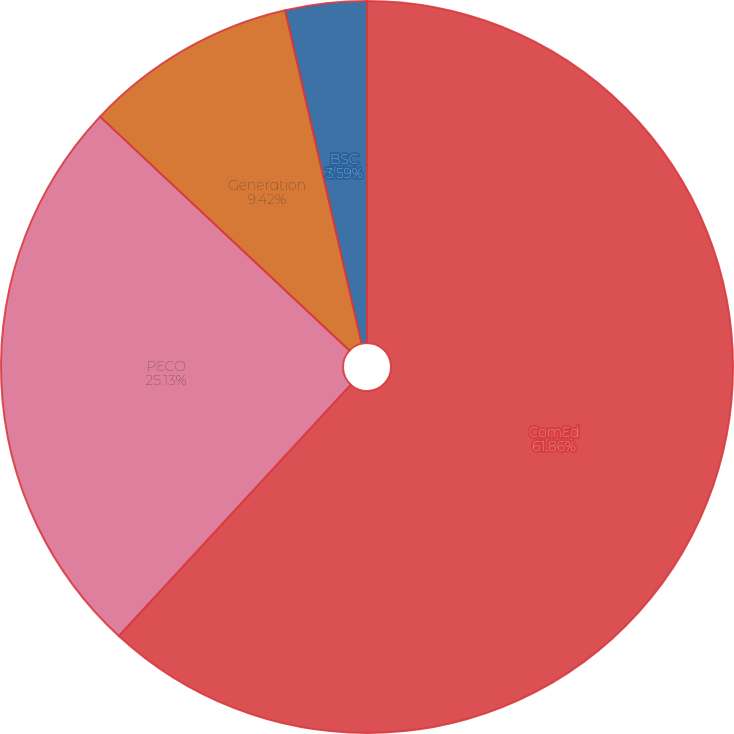Convert chart to OTSL. <chart><loc_0><loc_0><loc_500><loc_500><pie_chart><fcel>ComEd<fcel>PECO<fcel>Generation<fcel>BSC<nl><fcel>61.86%<fcel>25.13%<fcel>9.42%<fcel>3.59%<nl></chart> 